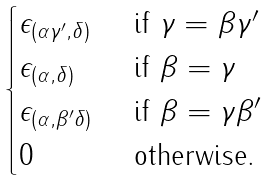Convert formula to latex. <formula><loc_0><loc_0><loc_500><loc_500>\begin{cases} \epsilon _ { ( \alpha \gamma ^ { \prime } , \delta ) } & \text { if $\gamma = \beta \gamma^{\prime}$} \\ \epsilon _ { ( \alpha , \delta ) } & \text { if $\beta = \gamma$} \\ \epsilon _ { ( \alpha , \beta ^ { \prime } \delta ) } & \text { if $\beta = \gamma \beta^{\prime}$} \\ 0 & \text { otherwise.} \end{cases}</formula> 